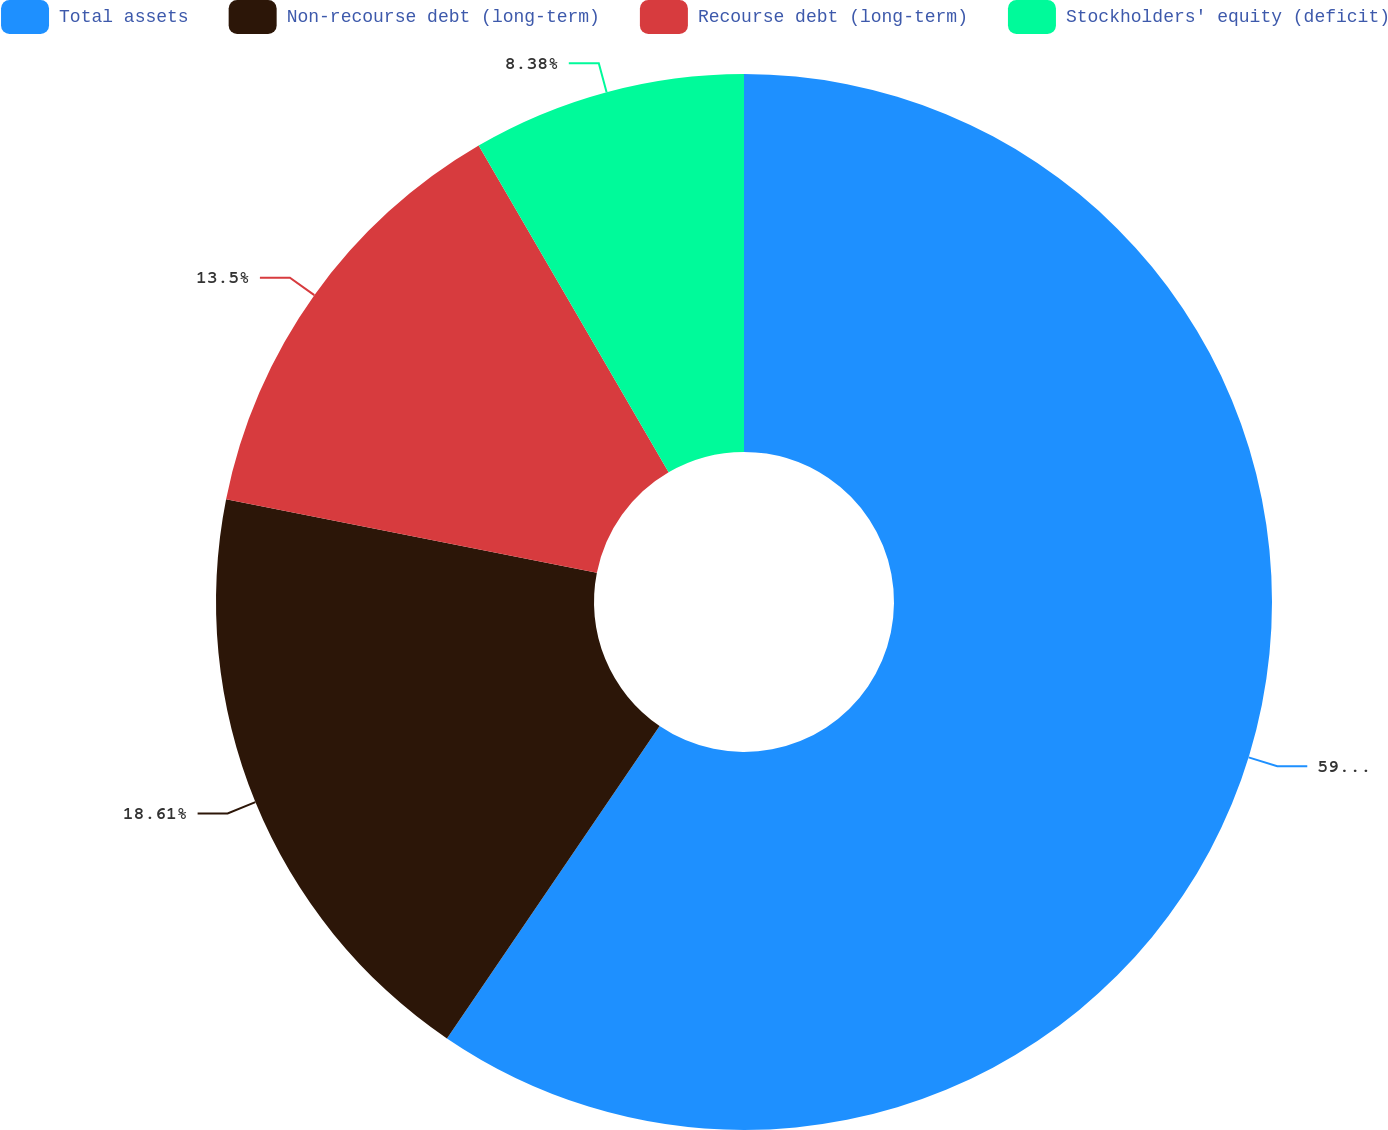Convert chart. <chart><loc_0><loc_0><loc_500><loc_500><pie_chart><fcel>Total assets<fcel>Non-recourse debt (long-term)<fcel>Recourse debt (long-term)<fcel>Stockholders' equity (deficit)<nl><fcel>59.51%<fcel>18.61%<fcel>13.5%<fcel>8.38%<nl></chart> 